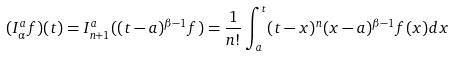<formula> <loc_0><loc_0><loc_500><loc_500>( I _ { \alpha } ^ { a } f ) ( t ) = I _ { n + 1 } ^ { a } ( ( t - a ) ^ { \beta - 1 } f ) = \frac { 1 } { n ! } \int _ { a } ^ { t } ( t - x ) ^ { n } ( x - a ) ^ { \beta - 1 } f ( x ) d x</formula> 